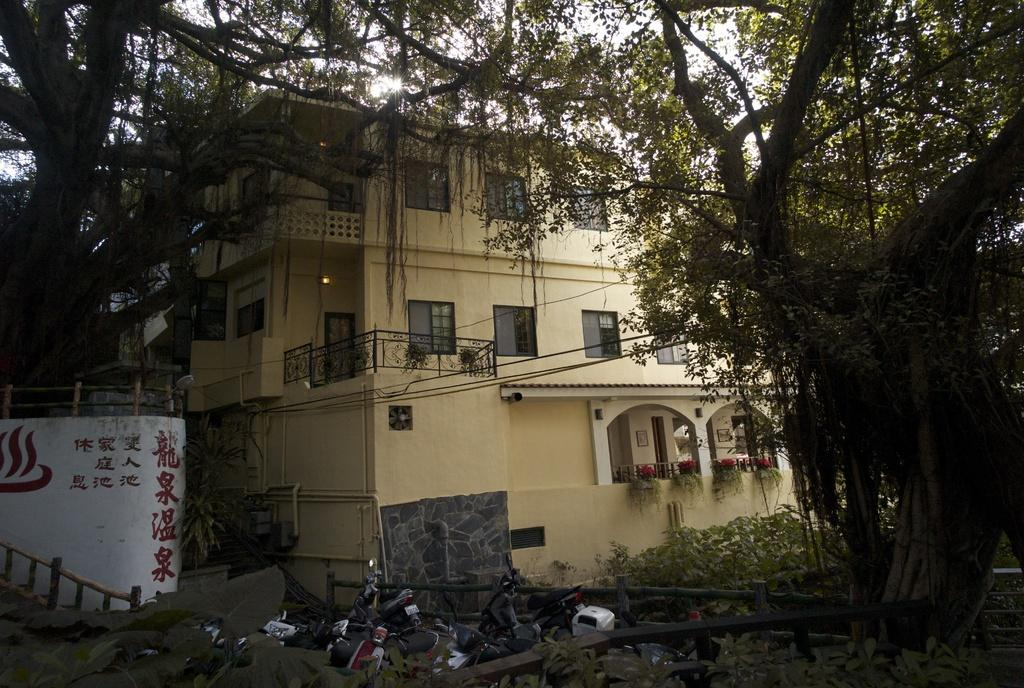What type of structure is present in the image? There is a building in the image. What can be seen illuminated in the image? There are lights in the image. What type of vegetation is present in the image? There are plants and trees in the image. What type of transportation is visible in the image? There are vehicles in the image. What is visible in the background of the image? The sky is visible in the background of the image. Where is the sheet used for playing games in the image? There is no sheet used for playing games present in the image. What type of lumber is being used to construct the building in the image? The image does not provide information about the construction materials of the building. 